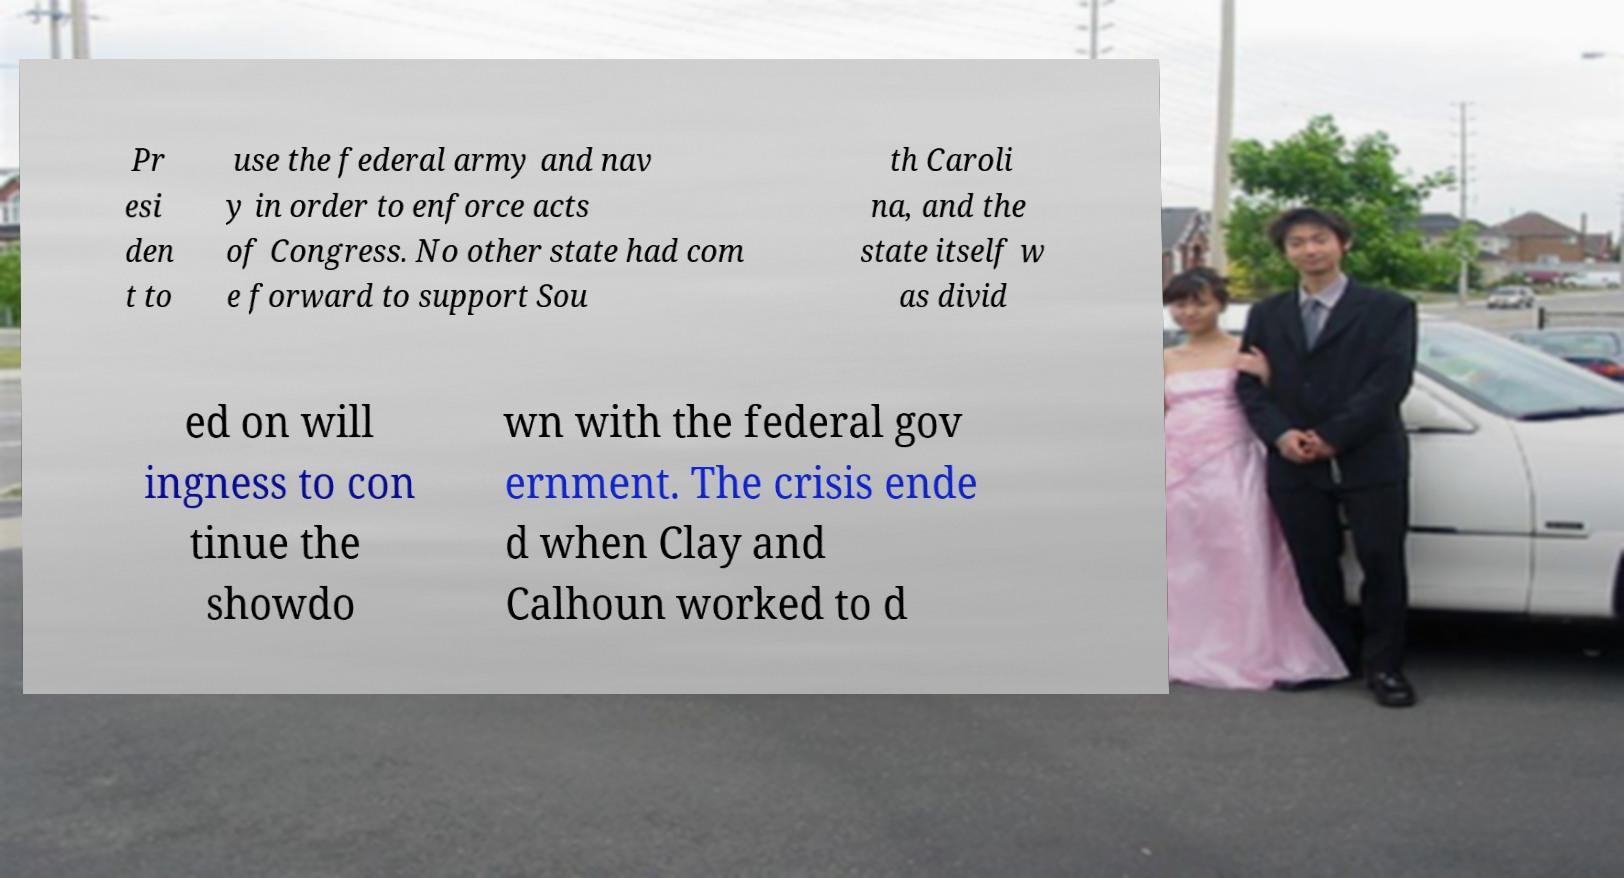Please read and relay the text visible in this image. What does it say? Pr esi den t to use the federal army and nav y in order to enforce acts of Congress. No other state had com e forward to support Sou th Caroli na, and the state itself w as divid ed on will ingness to con tinue the showdo wn with the federal gov ernment. The crisis ende d when Clay and Calhoun worked to d 